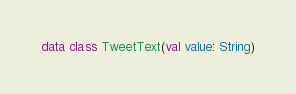<code> <loc_0><loc_0><loc_500><loc_500><_Kotlin_>
data class TweetText(val value: String)
</code> 